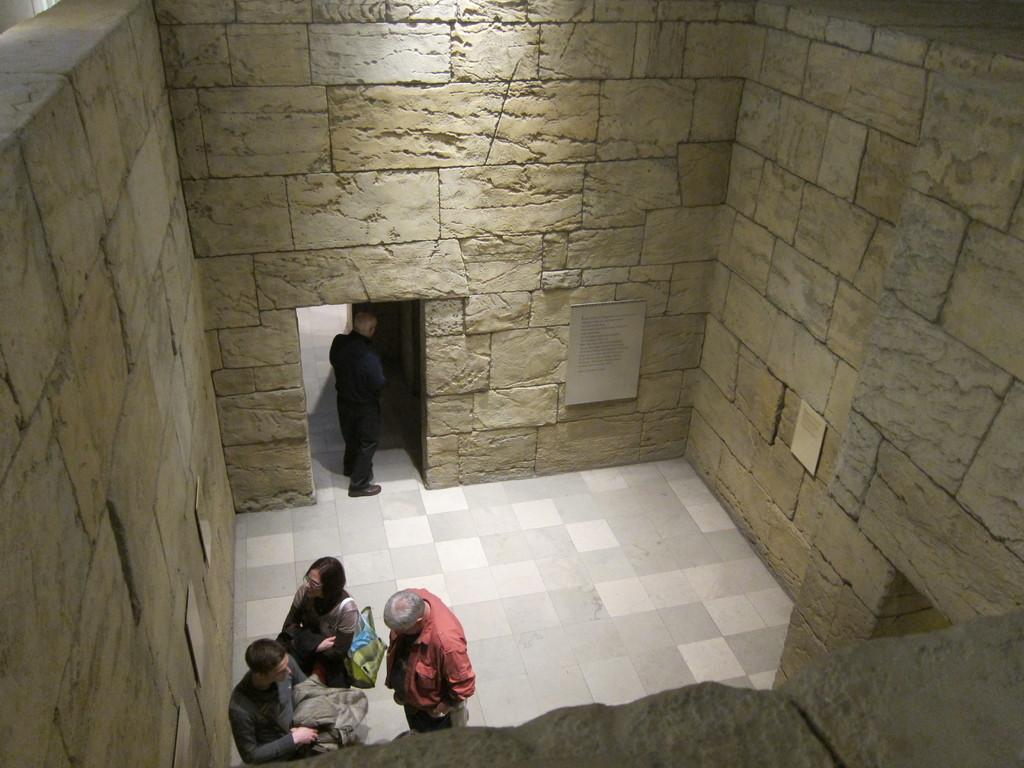How many people are present in the image? There are four persons standing in the image. What can be seen on the walls in the image? There are boards on the walls in the image. What color is the orange on the table in the image? There is no orange present in the image; it only mentions the presence of four persons and boards on the walls. 